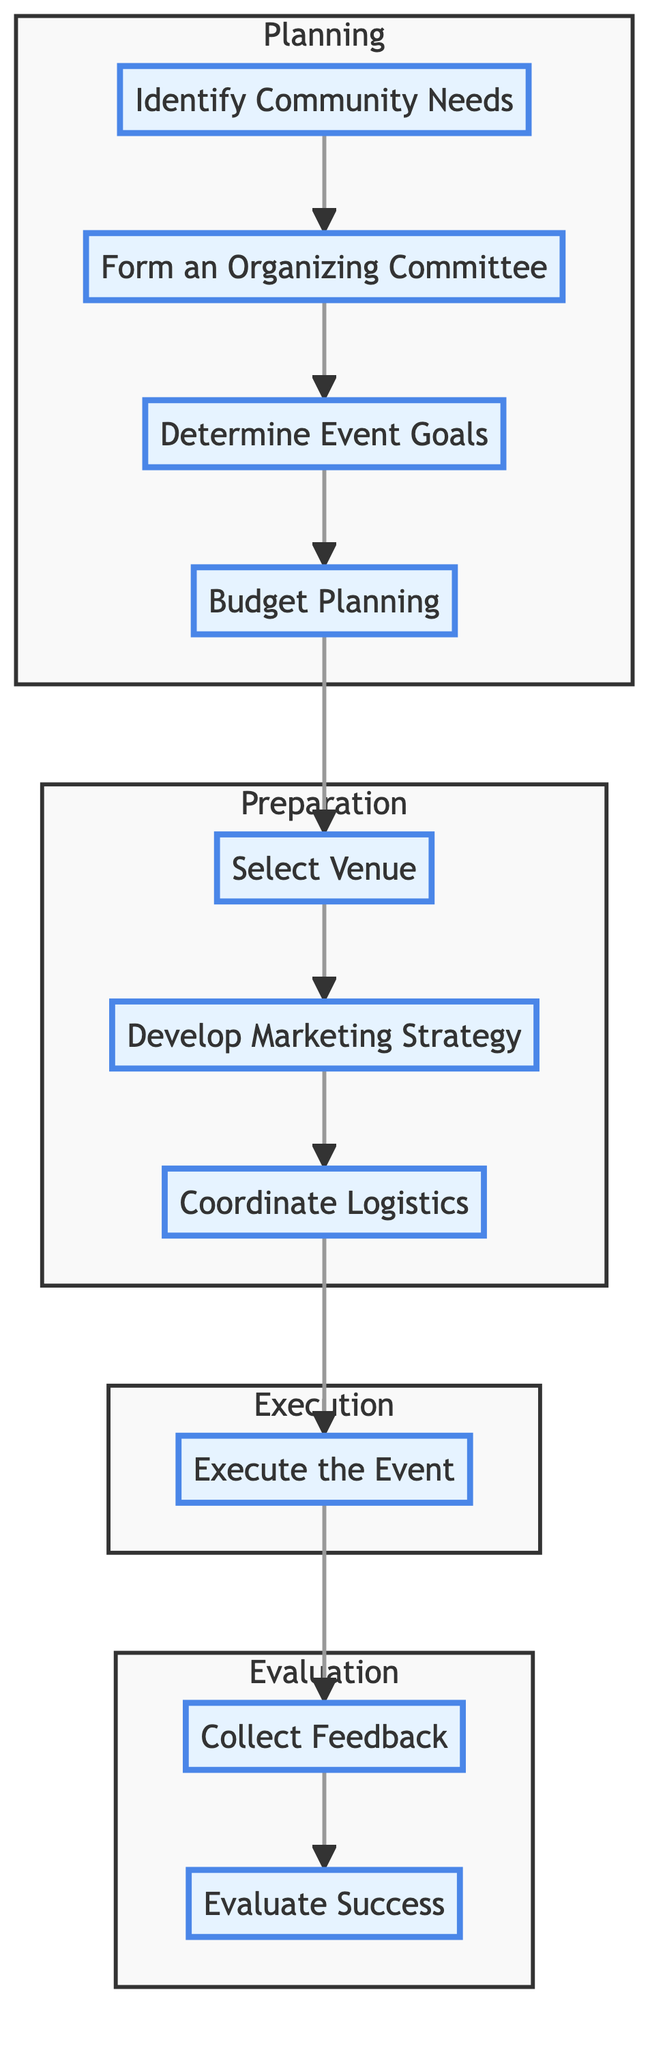What is the first step in the flow? The first step in the flow is indicated as the top node, which is "Identify Community Needs." It is the starting point of the entire process.
Answer: Identify Community Needs How many main sections are present in the diagram? The diagram has four main sections: Planning, Preparation, Execution, and Evaluation. Each section groups related steps, so counting these gives four.
Answer: Four What is the final step of the process? The last step of the process is shown at the bottom of the diagram, which is "Evaluate Success." It concludes the overall event organization process.
Answer: Evaluate Success What step follows 'Budget Planning'? The step that follows 'Budget Planning' is 'Select Venue.' This can be determined by following the directional arrows from 'Budget Planning' to the next node in the flowchart.
Answer: Select Venue What is the relationship between 'Collect Feedback' and 'Evaluate Success'? 'Collect Feedback' is a prerequisite for 'Evaluate Success,' as indicated by the directional arrow connecting the two. Feedback must be gathered before assessing the overall success of the event.
Answer: Collect Feedback is a prerequisite Which step involves forming the committee? The step that involves forming the committee is 'Form an Organizing Committee.' It comes immediately after gathering community needs.
Answer: Form an Organizing Committee What step is directly related to promoting the event? The step directly related to promoting the event is 'Develop Marketing Strategy,' which focuses on creating awareness about the event through various promotional means.
Answer: Develop Marketing Strategy Which section does 'Execute the Event' fall under? 'Execute the Event' falls under the Execution section of the diagram. This section encompasses actions that take place during the event itself.
Answer: Execution What must be done immediately after executing the event? Immediately after executing the event, 'Collect Feedback' must be done, as it's the next logical step in assessing the event's impact.
Answer: Collect Feedback 